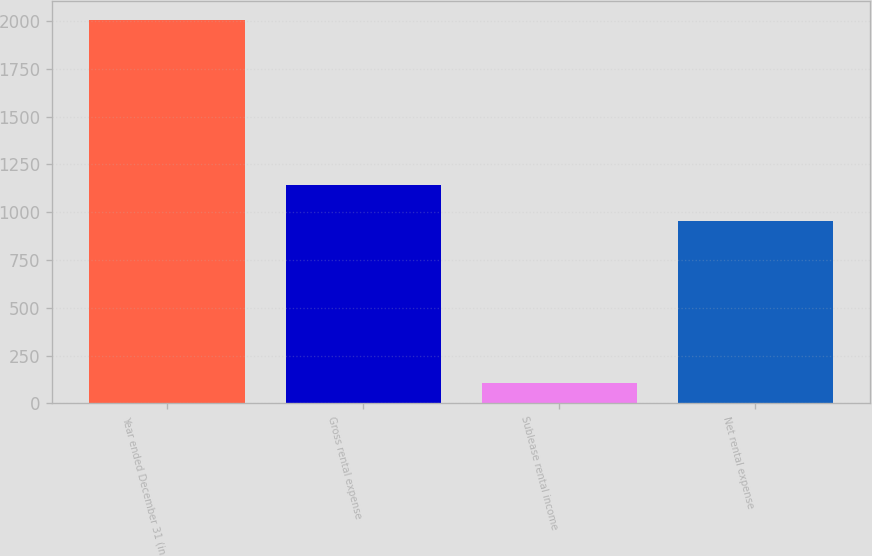<chart> <loc_0><loc_0><loc_500><loc_500><bar_chart><fcel>Year ended December 31 (in<fcel>Gross rental expense<fcel>Sublease rental income<fcel>Net rental expense<nl><fcel>2003<fcel>1144.7<fcel>106<fcel>955<nl></chart> 